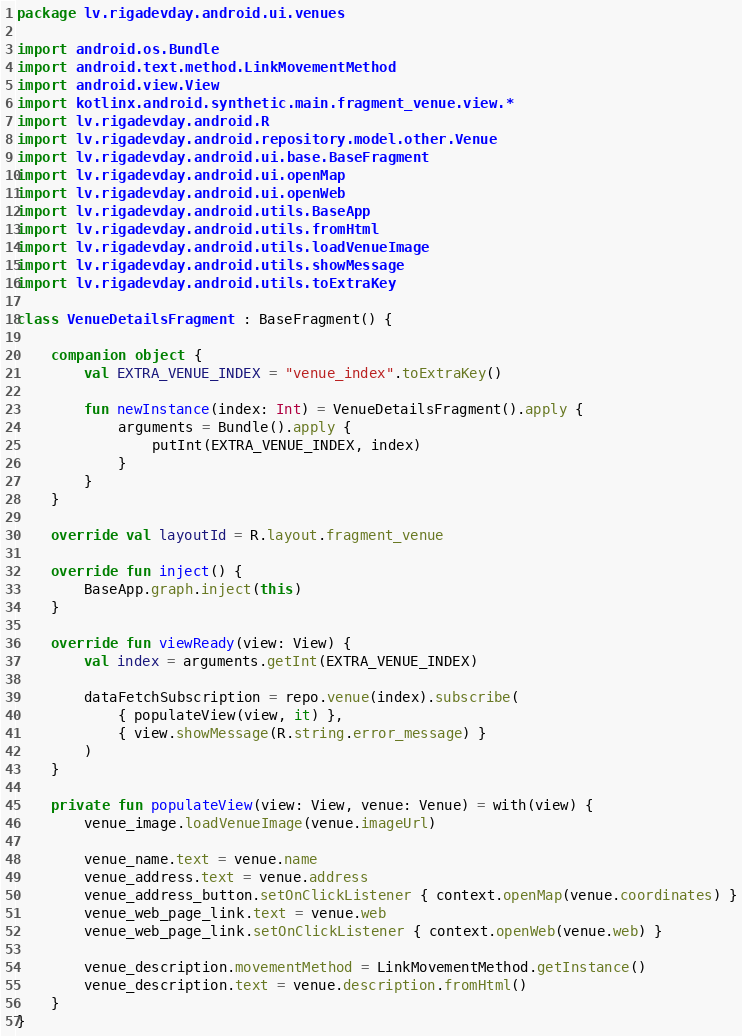<code> <loc_0><loc_0><loc_500><loc_500><_Kotlin_>package lv.rigadevday.android.ui.venues

import android.os.Bundle
import android.text.method.LinkMovementMethod
import android.view.View
import kotlinx.android.synthetic.main.fragment_venue.view.*
import lv.rigadevday.android.R
import lv.rigadevday.android.repository.model.other.Venue
import lv.rigadevday.android.ui.base.BaseFragment
import lv.rigadevday.android.ui.openMap
import lv.rigadevday.android.ui.openWeb
import lv.rigadevday.android.utils.BaseApp
import lv.rigadevday.android.utils.fromHtml
import lv.rigadevday.android.utils.loadVenueImage
import lv.rigadevday.android.utils.showMessage
import lv.rigadevday.android.utils.toExtraKey

class VenueDetailsFragment : BaseFragment() {

    companion object {
        val EXTRA_VENUE_INDEX = "venue_index".toExtraKey()

        fun newInstance(index: Int) = VenueDetailsFragment().apply {
            arguments = Bundle().apply {
                putInt(EXTRA_VENUE_INDEX, index)
            }
        }
    }

    override val layoutId = R.layout.fragment_venue

    override fun inject() {
        BaseApp.graph.inject(this)
    }

    override fun viewReady(view: View) {
        val index = arguments.getInt(EXTRA_VENUE_INDEX)

        dataFetchSubscription = repo.venue(index).subscribe(
            { populateView(view, it) },
            { view.showMessage(R.string.error_message) }
        )
    }

    private fun populateView(view: View, venue: Venue) = with(view) {
        venue_image.loadVenueImage(venue.imageUrl)

        venue_name.text = venue.name
        venue_address.text = venue.address
        venue_address_button.setOnClickListener { context.openMap(venue.coordinates) }
        venue_web_page_link.text = venue.web
        venue_web_page_link.setOnClickListener { context.openWeb(venue.web) }

        venue_description.movementMethod = LinkMovementMethod.getInstance()
        venue_description.text = venue.description.fromHtml()
    }
}
</code> 